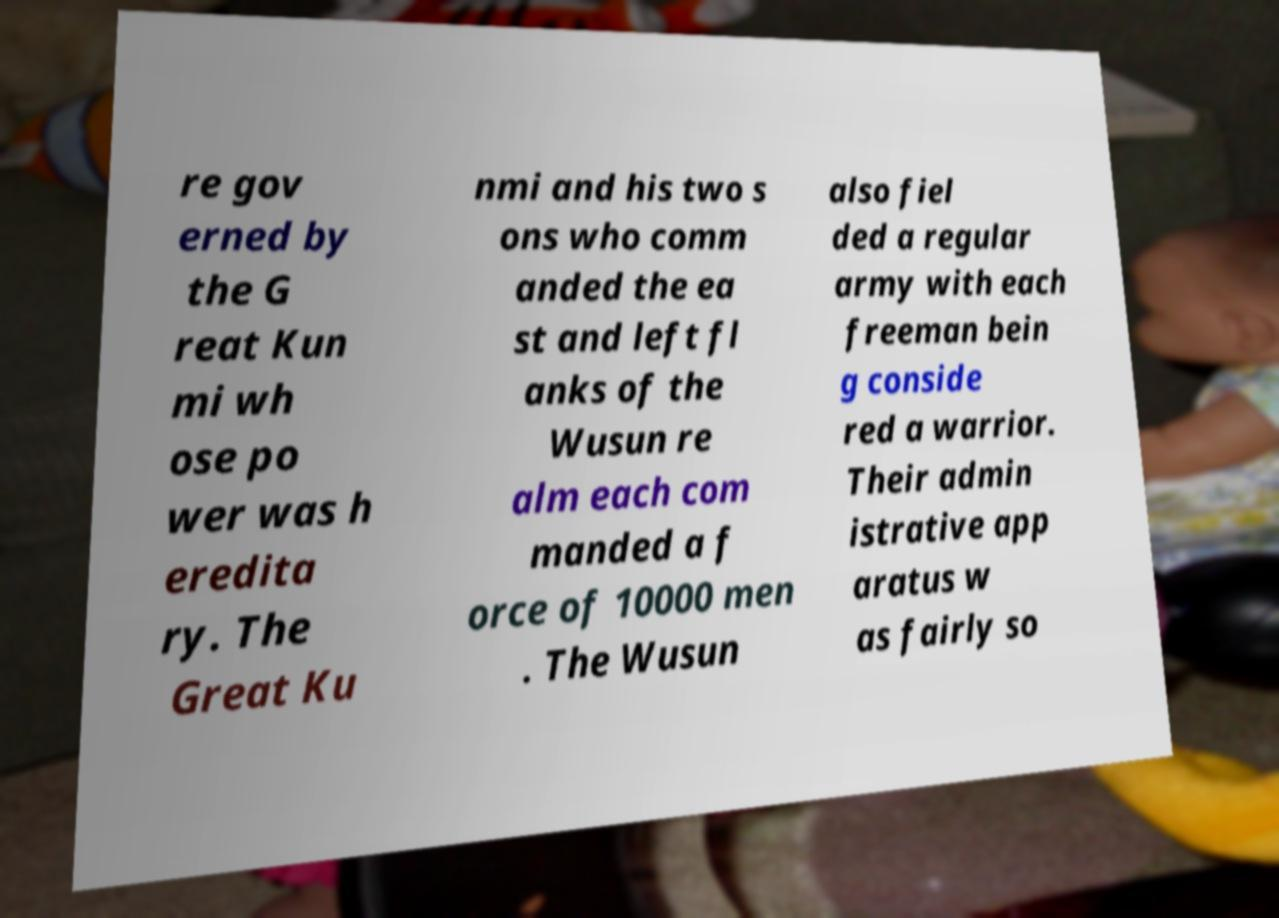Can you accurately transcribe the text from the provided image for me? re gov erned by the G reat Kun mi wh ose po wer was h eredita ry. The Great Ku nmi and his two s ons who comm anded the ea st and left fl anks of the Wusun re alm each com manded a f orce of 10000 men . The Wusun also fiel ded a regular army with each freeman bein g conside red a warrior. Their admin istrative app aratus w as fairly so 